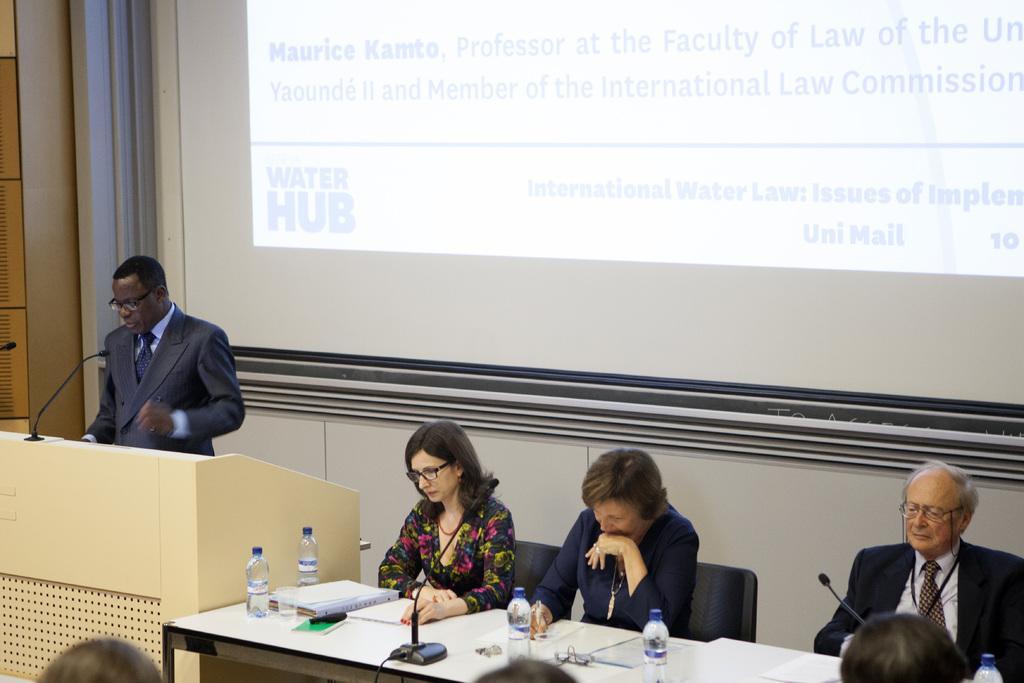Can you describe this image briefly? In this picture we can see a man who is standing and talking on the mike. Here we can see three persons sitting on the chairs. This is the table, on the table there is a file, bottle, and paper. And there is a screen and this is the wall. 